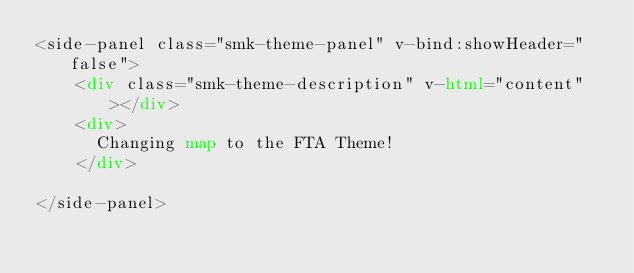<code> <loc_0><loc_0><loc_500><loc_500><_HTML_><side-panel class="smk-theme-panel" v-bind:showHeader="false">
    <div class="smk-theme-description" v-html="content"></div>
    <div>
    	Changing map to the FTA Theme!
    </div>
    
</side-panel>
</code> 